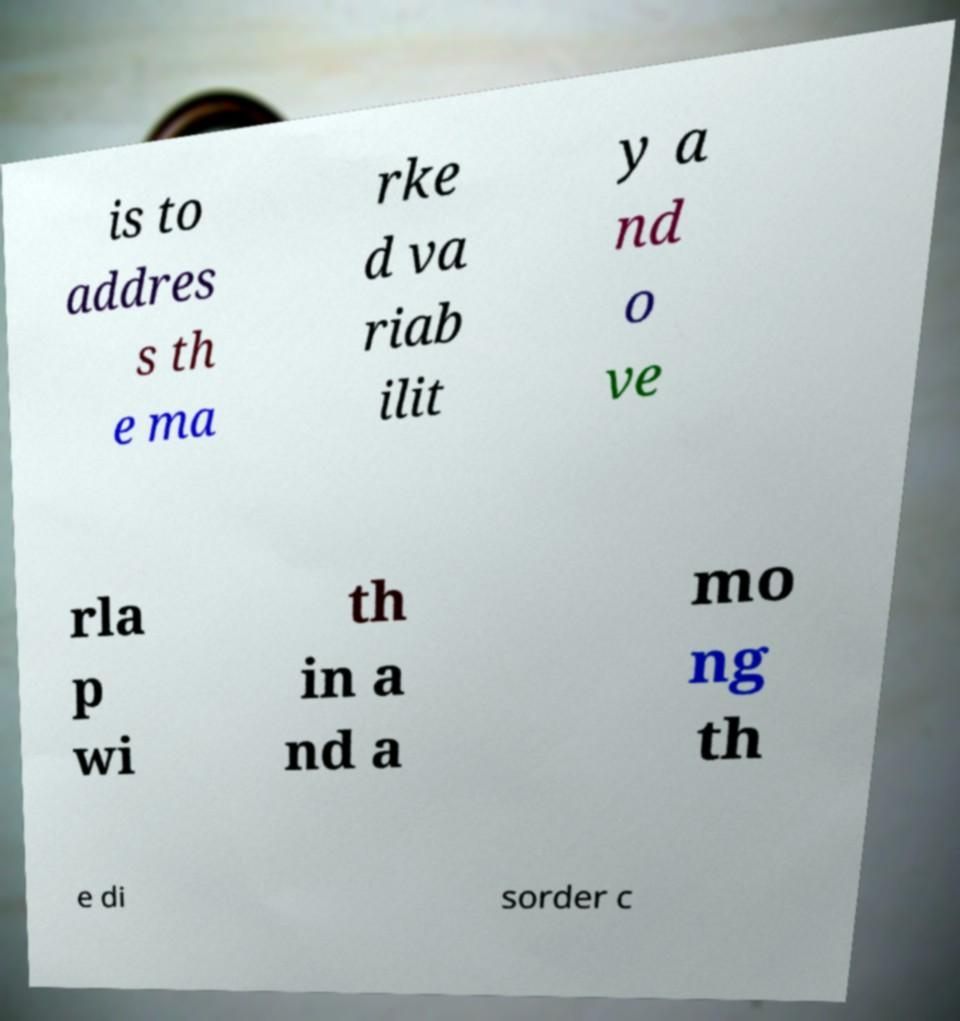I need the written content from this picture converted into text. Can you do that? is to addres s th e ma rke d va riab ilit y a nd o ve rla p wi th in a nd a mo ng th e di sorder c 